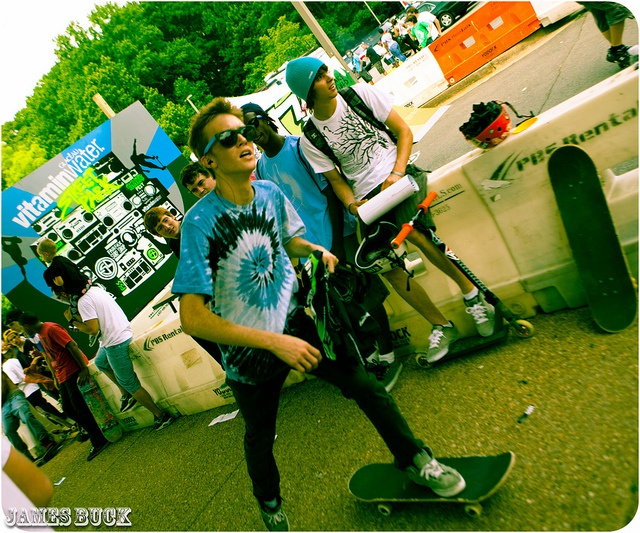Describe the objects in this image and their specific colors. I can see people in white, black, olive, darkgreen, and teal tones, people in white, black, lavender, and darkgreen tones, skateboard in white, darkgreen, and olive tones, people in white, black, lavender, and darkgreen tones, and people in white, black, and teal tones in this image. 